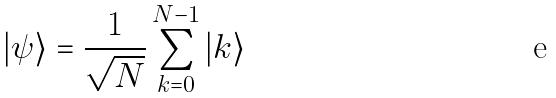<formula> <loc_0><loc_0><loc_500><loc_500>| \psi \rangle = \frac { 1 } { \sqrt { N } } \sum _ { k = 0 } ^ { N - 1 } | k \rangle</formula> 